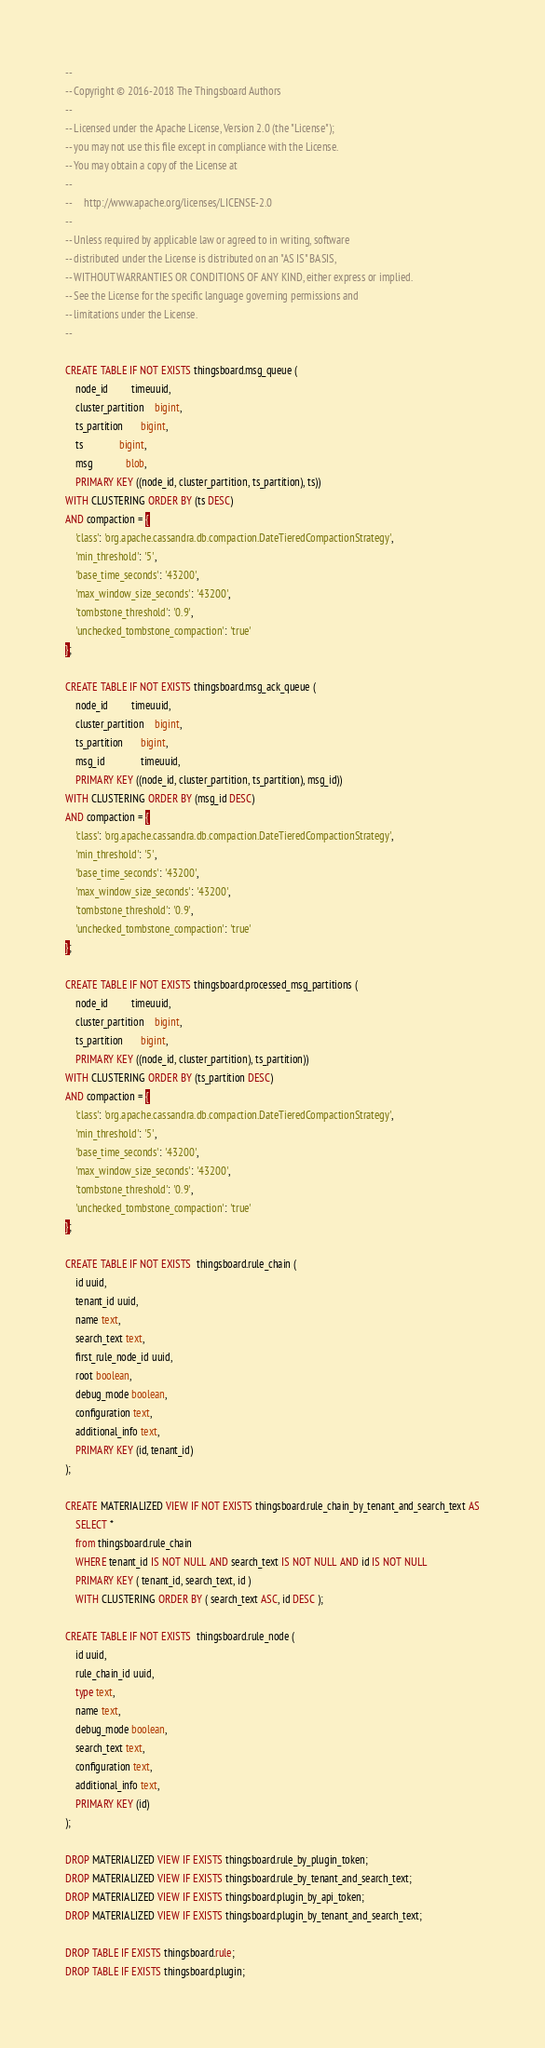<code> <loc_0><loc_0><loc_500><loc_500><_SQL_>--
-- Copyright © 2016-2018 The Thingsboard Authors
--
-- Licensed under the Apache License, Version 2.0 (the "License");
-- you may not use this file except in compliance with the License.
-- You may obtain a copy of the License at
--
--     http://www.apache.org/licenses/LICENSE-2.0
--
-- Unless required by applicable law or agreed to in writing, software
-- distributed under the License is distributed on an "AS IS" BASIS,
-- WITHOUT WARRANTIES OR CONDITIONS OF ANY KIND, either express or implied.
-- See the License for the specific language governing permissions and
-- limitations under the License.
--

CREATE TABLE IF NOT EXISTS thingsboard.msg_queue (
    node_id         timeuuid,
    cluster_partition    bigint,
    ts_partition       bigint,
    ts              bigint,
    msg             blob,
	PRIMARY KEY ((node_id, cluster_partition, ts_partition), ts))
WITH CLUSTERING ORDER BY (ts DESC)
AND compaction = {
    'class': 'org.apache.cassandra.db.compaction.DateTieredCompactionStrategy',
    'min_threshold': '5',
    'base_time_seconds': '43200',
    'max_window_size_seconds': '43200',
    'tombstone_threshold': '0.9',
    'unchecked_tombstone_compaction': 'true'
};

CREATE TABLE IF NOT EXISTS thingsboard.msg_ack_queue (
    node_id         timeuuid,
    cluster_partition    bigint,
    ts_partition       bigint,
    msg_id              timeuuid,
	PRIMARY KEY ((node_id, cluster_partition, ts_partition), msg_id))
WITH CLUSTERING ORDER BY (msg_id DESC)
AND compaction = {
    'class': 'org.apache.cassandra.db.compaction.DateTieredCompactionStrategy',
    'min_threshold': '5',
    'base_time_seconds': '43200',
    'max_window_size_seconds': '43200',
    'tombstone_threshold': '0.9',
    'unchecked_tombstone_compaction': 'true'
};

CREATE TABLE IF NOT EXISTS thingsboard.processed_msg_partitions (
    node_id         timeuuid,
    cluster_partition    bigint,
    ts_partition       bigint,
	PRIMARY KEY ((node_id, cluster_partition), ts_partition))
WITH CLUSTERING ORDER BY (ts_partition DESC)
AND compaction = {
    'class': 'org.apache.cassandra.db.compaction.DateTieredCompactionStrategy',
    'min_threshold': '5',
    'base_time_seconds': '43200',
    'max_window_size_seconds': '43200',
    'tombstone_threshold': '0.9',
    'unchecked_tombstone_compaction': 'true'
};

CREATE TABLE IF NOT EXISTS  thingsboard.rule_chain (
    id uuid,
    tenant_id uuid,
    name text,
    search_text text,
    first_rule_node_id uuid,
    root boolean,
    debug_mode boolean,
    configuration text,
    additional_info text,
    PRIMARY KEY (id, tenant_id)
);

CREATE MATERIALIZED VIEW IF NOT EXISTS thingsboard.rule_chain_by_tenant_and_search_text AS
    SELECT *
    from thingsboard.rule_chain
    WHERE tenant_id IS NOT NULL AND search_text IS NOT NULL AND id IS NOT NULL
    PRIMARY KEY ( tenant_id, search_text, id )
    WITH CLUSTERING ORDER BY ( search_text ASC, id DESC );

CREATE TABLE IF NOT EXISTS  thingsboard.rule_node (
    id uuid,
    rule_chain_id uuid,
    type text,
    name text,
    debug_mode boolean,
    search_text text,
    configuration text,
    additional_info text,
    PRIMARY KEY (id)
);

DROP MATERIALIZED VIEW IF EXISTS thingsboard.rule_by_plugin_token;
DROP MATERIALIZED VIEW IF EXISTS thingsboard.rule_by_tenant_and_search_text;
DROP MATERIALIZED VIEW IF EXISTS thingsboard.plugin_by_api_token;
DROP MATERIALIZED VIEW IF EXISTS thingsboard.plugin_by_tenant_and_search_text;

DROP TABLE IF EXISTS thingsboard.rule;
DROP TABLE IF EXISTS thingsboard.plugin;
</code> 